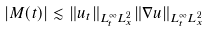Convert formula to latex. <formula><loc_0><loc_0><loc_500><loc_500>| M ( t ) | & \lesssim \| u _ { t } \| _ { L _ { t } ^ { \infty } L _ { x } ^ { 2 } } \| \nabla u \| _ { L _ { t } ^ { \infty } L _ { x } ^ { 2 } }</formula> 